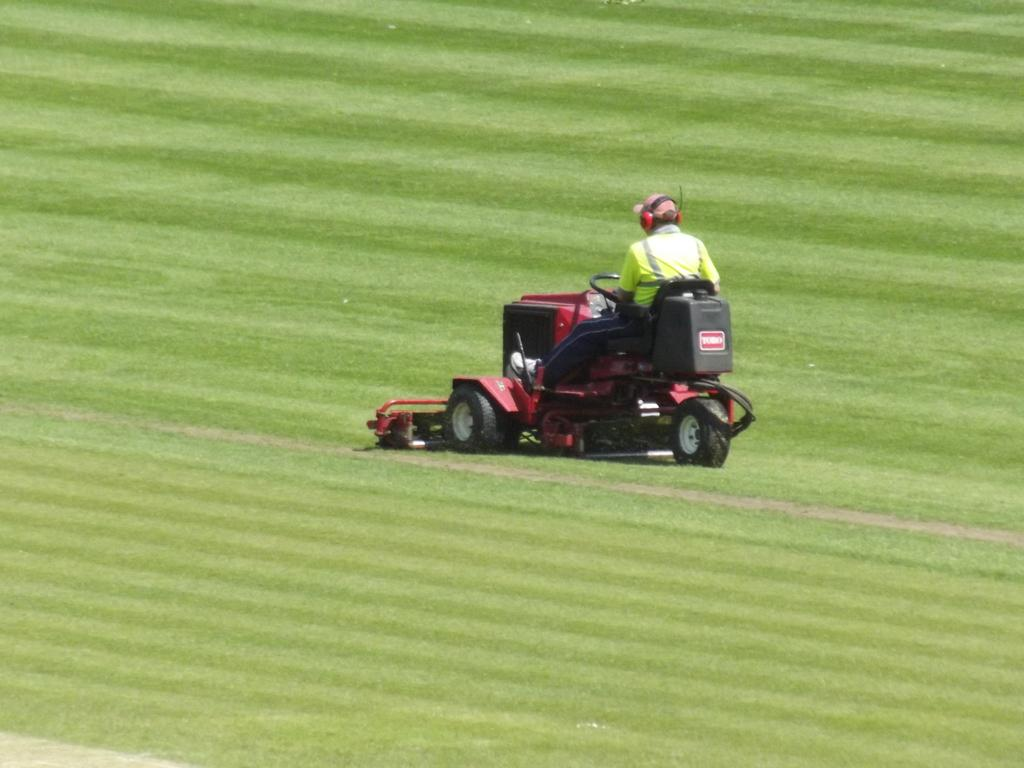What is happening in the image? There is a person in the image who is driving a vehicle. What is the location of the vehicle in the image? The vehicle is on the ground. What type of drink is the goose holding while wearing a mask in the image? There is no goose, drink, or mask present in the image. 